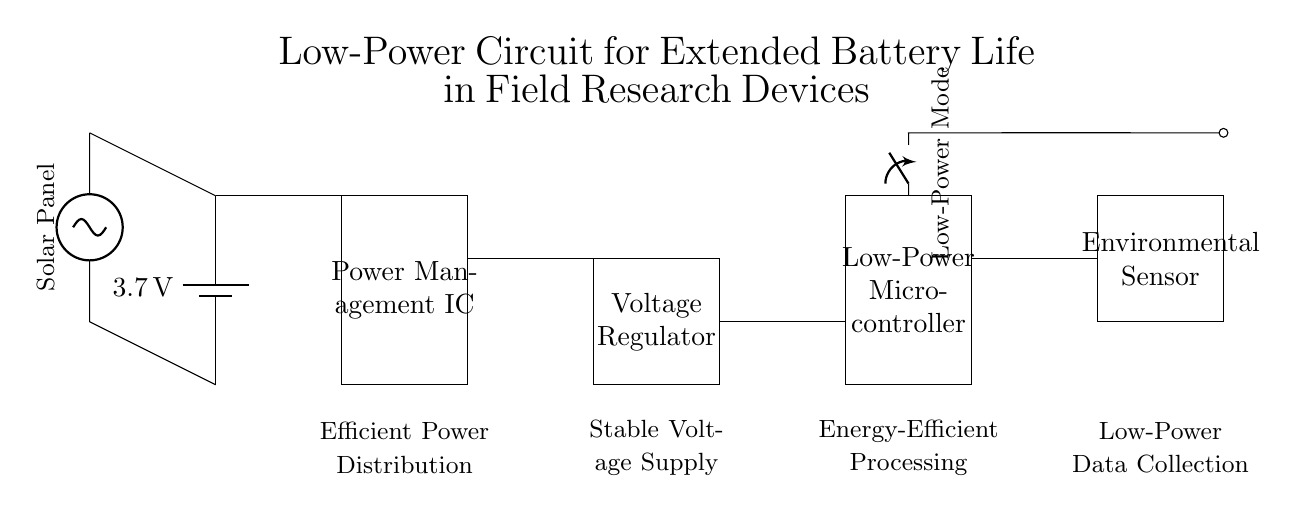What is the voltage of the battery? The voltage of the battery is labeled as 3.7 volts, which is the potential difference it provides to the circuit.
Answer: 3.7 volts What component manages the power in the circuit? The component labeled "Power Management IC" is responsible for managing the power distribution, ensuring efficient usage of the battery supply.
Answer: Power Management IC What is the primary function of the low-power microcontroller? The low-power microcontroller is designed for energy-efficient processing, which means it manages operations while consuming minimal power, extending battery life during field research.
Answer: Energy-efficient processing How many main components are in this circuit? The circuit includes one battery, one power management IC, one voltage regulator, one low-power microcontroller, and one environmental sensor, totaling five main components.
Answer: Five What does the low-power mode switch do? The low-power mode switch allows the microcontroller to operate in a reduced power state, which is essential for prolonging battery life during field research when full capacity isn’t needed.
Answer: Reduces power consumption What external energy source is incorporated into the circuit? The circuit includes a solar panel, which serves as an external energy source by converting solar energy into electrical energy, potentially extending battery life further while in the field.
Answer: Solar panel What connection type is used between the battery and the power management IC? The connection between the battery and the power management IC is a direct connection indicated by a line, suggesting it directly feeds the power to the IC with no interruption or additional components.
Answer: Direct connection 